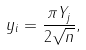<formula> <loc_0><loc_0><loc_500><loc_500>y _ { i } = \frac { \pi Y _ { j } } { 2 \sqrt { n } } ,</formula> 